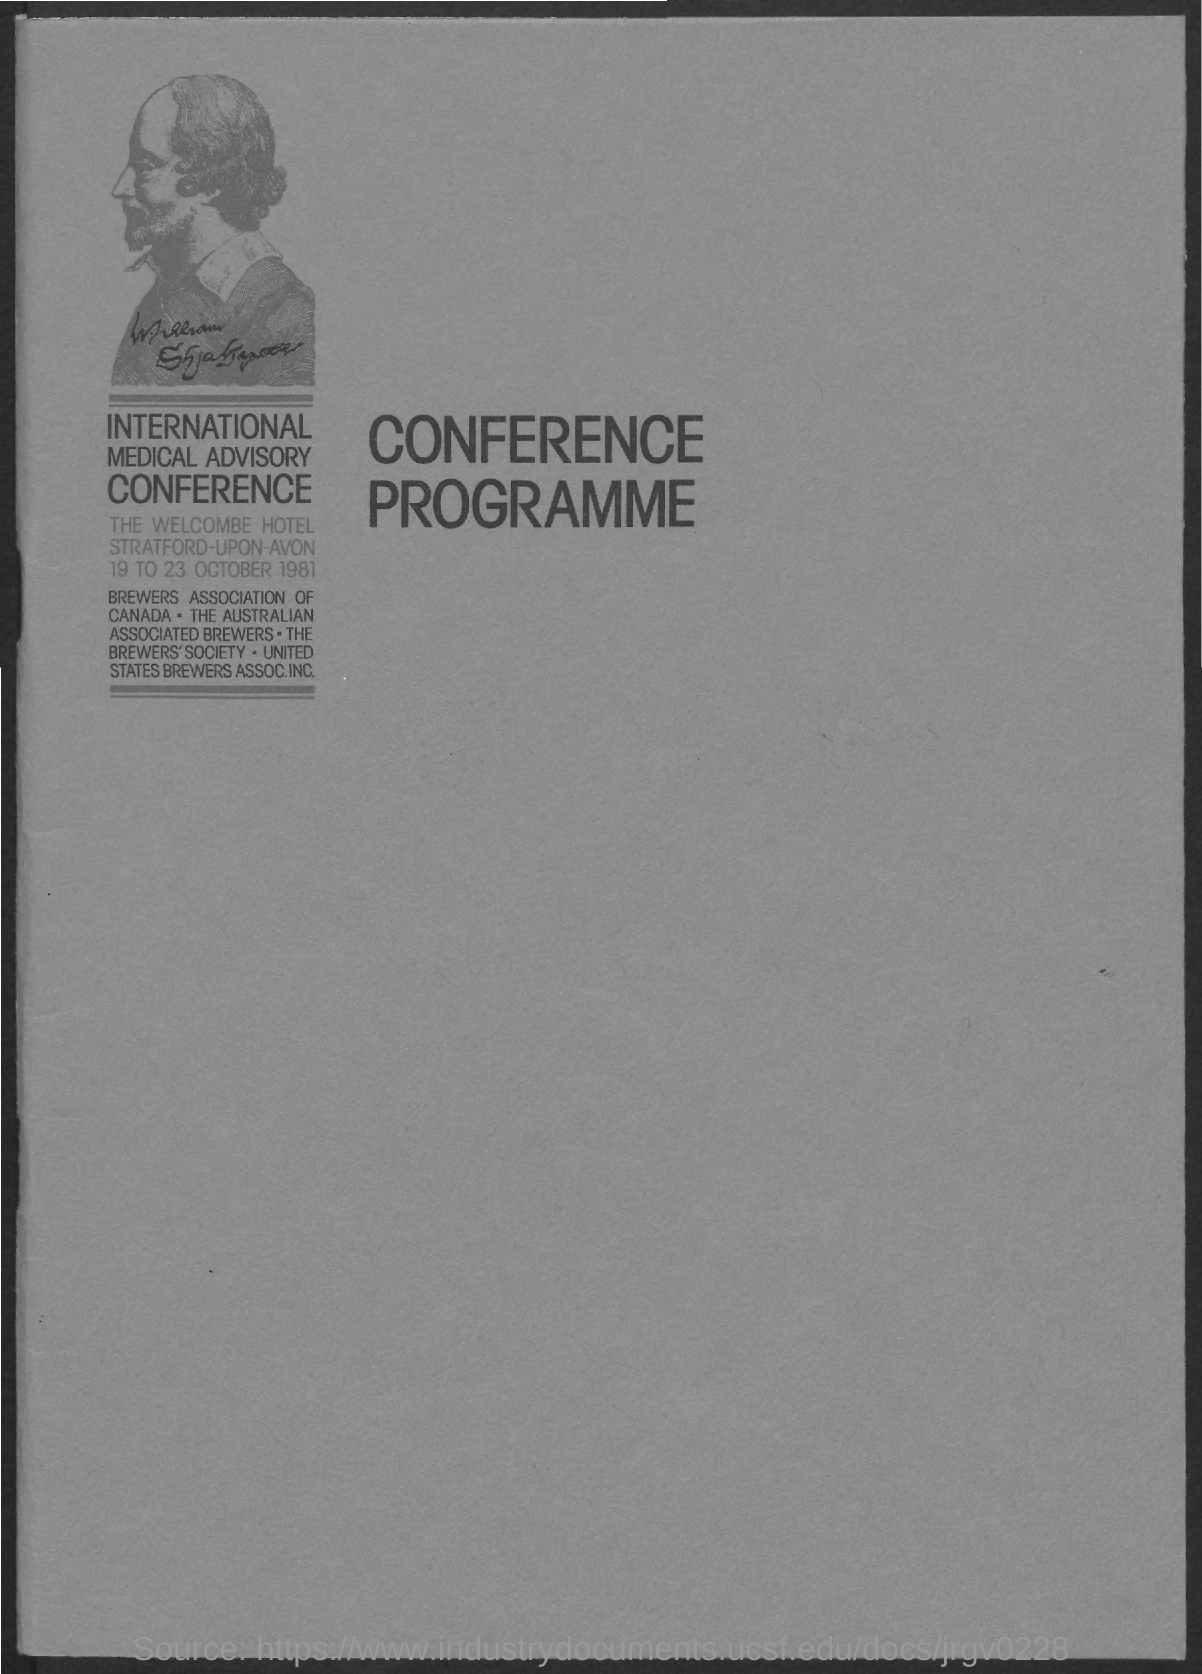Specify some key components in this picture. The International Medical Advisory Conference was held from 19 to 23 October 1981. 